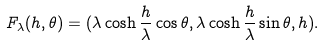<formula> <loc_0><loc_0><loc_500><loc_500>F _ { \lambda } ( h , \theta ) = ( \lambda \cosh \frac { h } { \lambda } \cos \theta , \lambda \cosh \frac { h } { \lambda } \sin \theta , h ) .</formula> 